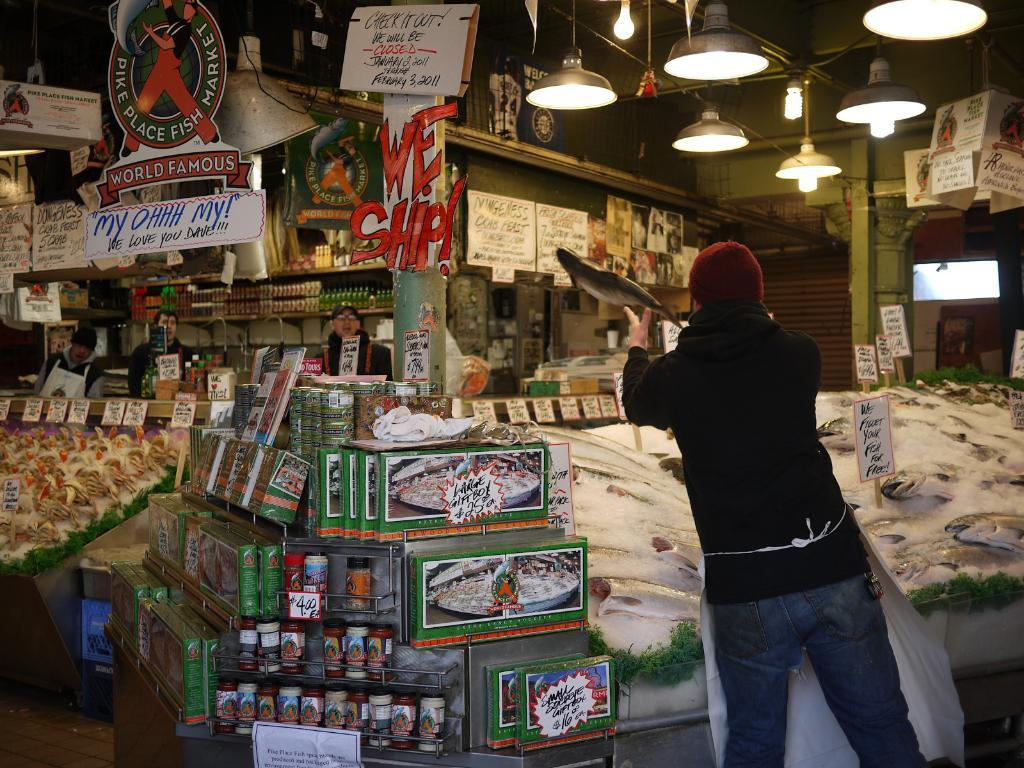<image>
Offer a succinct explanation of the picture presented. A fish is being tossed in the air, near a sign that says "we ship!". 